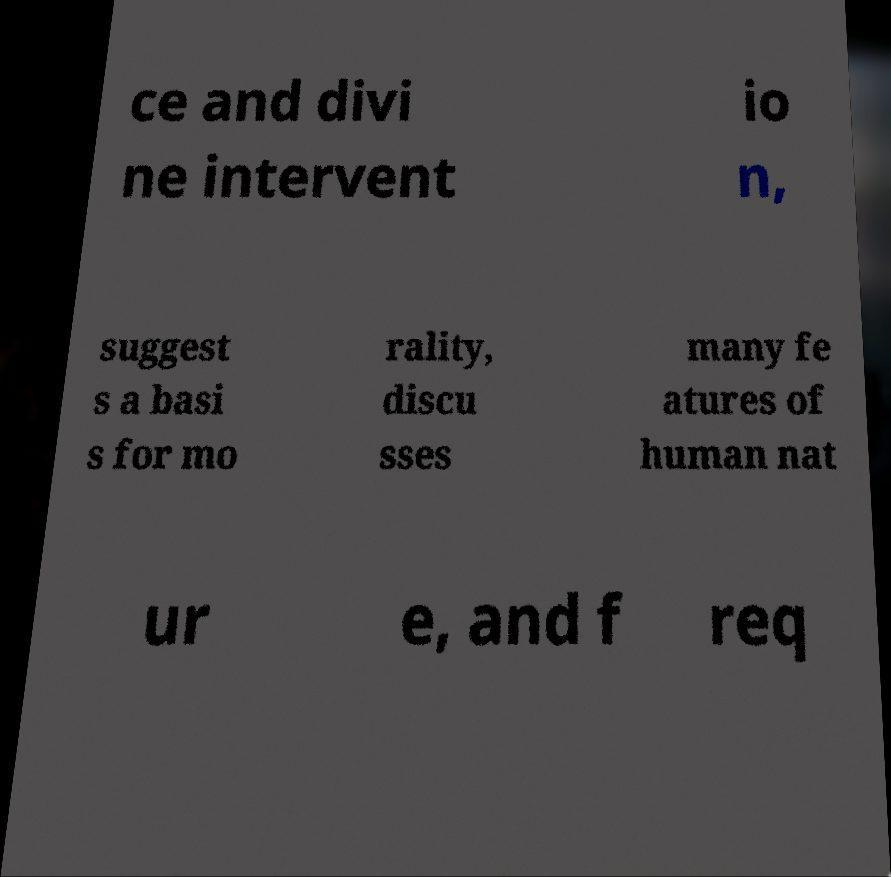Please read and relay the text visible in this image. What does it say? ce and divi ne intervent io n, suggest s a basi s for mo rality, discu sses many fe atures of human nat ur e, and f req 